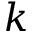<formula> <loc_0><loc_0><loc_500><loc_500>k</formula> 